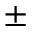Convert formula to latex. <formula><loc_0><loc_0><loc_500><loc_500>\pm</formula> 